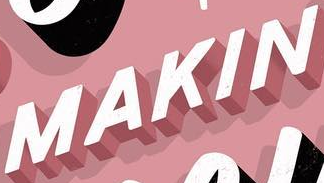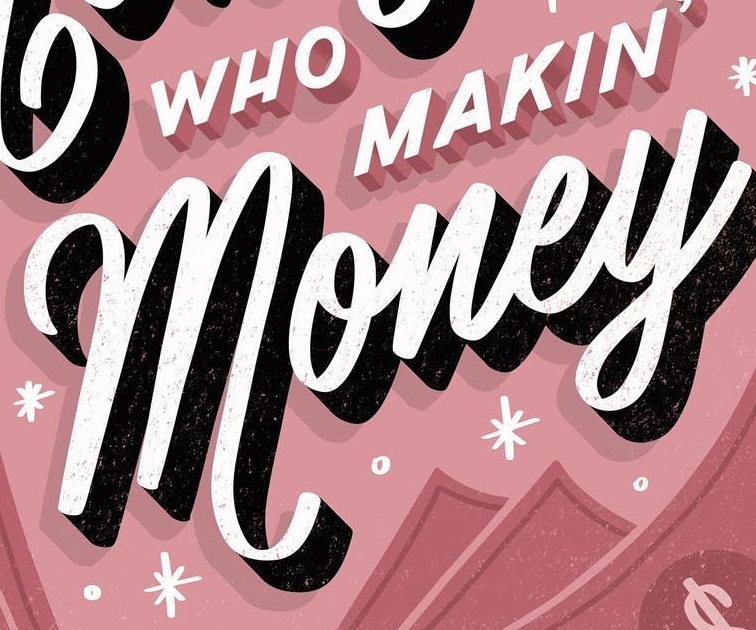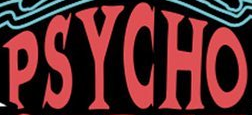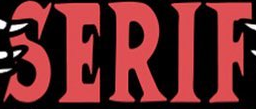What text appears in these images from left to right, separated by a semicolon? MAKIN; money; PSYCHO; SERIF 